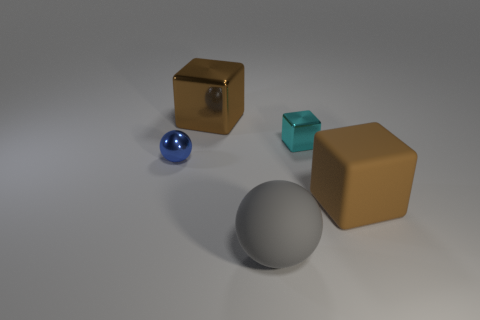Do the blue metallic ball and the brown matte thing have the same size?
Offer a very short reply. No. Is there a large red metallic object?
Your answer should be compact. No. There is a shiny cube left of the shiny block on the right side of the big object in front of the brown rubber thing; what is its size?
Your answer should be very brief. Large. How many spheres have the same material as the cyan block?
Ensure brevity in your answer.  1. How many cyan objects are the same size as the shiny sphere?
Your answer should be very brief. 1. What material is the big thing that is in front of the big brown cube that is in front of the cube that is left of the large gray matte ball?
Provide a succinct answer. Rubber. How many things are either brown things or small blue metallic objects?
Your answer should be compact. 3. What is the shape of the blue thing?
Your answer should be very brief. Sphere. What shape is the tiny metal thing that is right of the thing behind the small cyan metallic object?
Give a very brief answer. Cube. Does the cube that is behind the small metal block have the same material as the blue sphere?
Provide a short and direct response. Yes. 